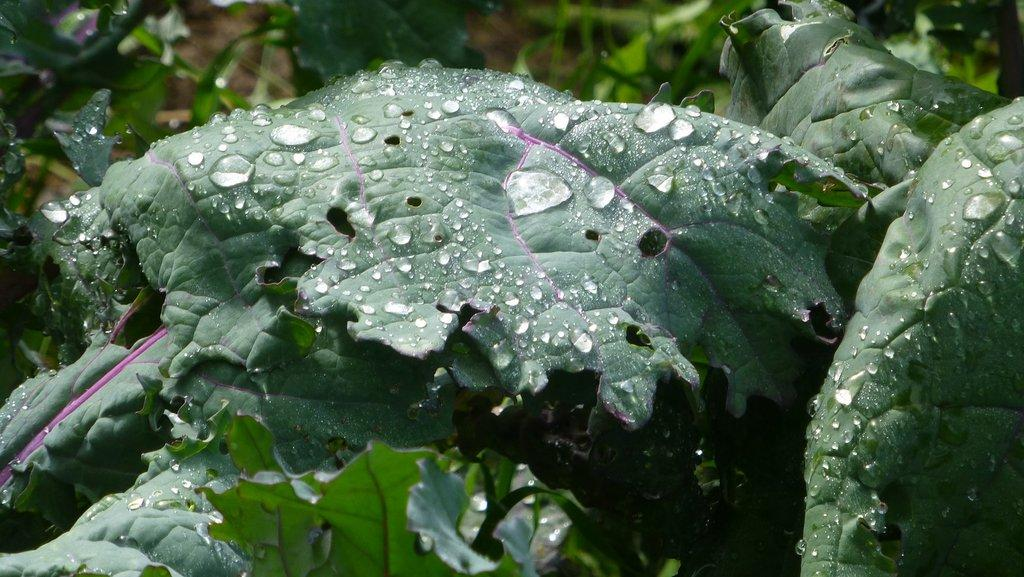What is present on the leaves in the image? There are water drops on the leaves in the image. What type of riddle can be solved using the kettle in the garden from the image? There is no kettle or garden present in the image, and therefore no such riddle can be solved. 